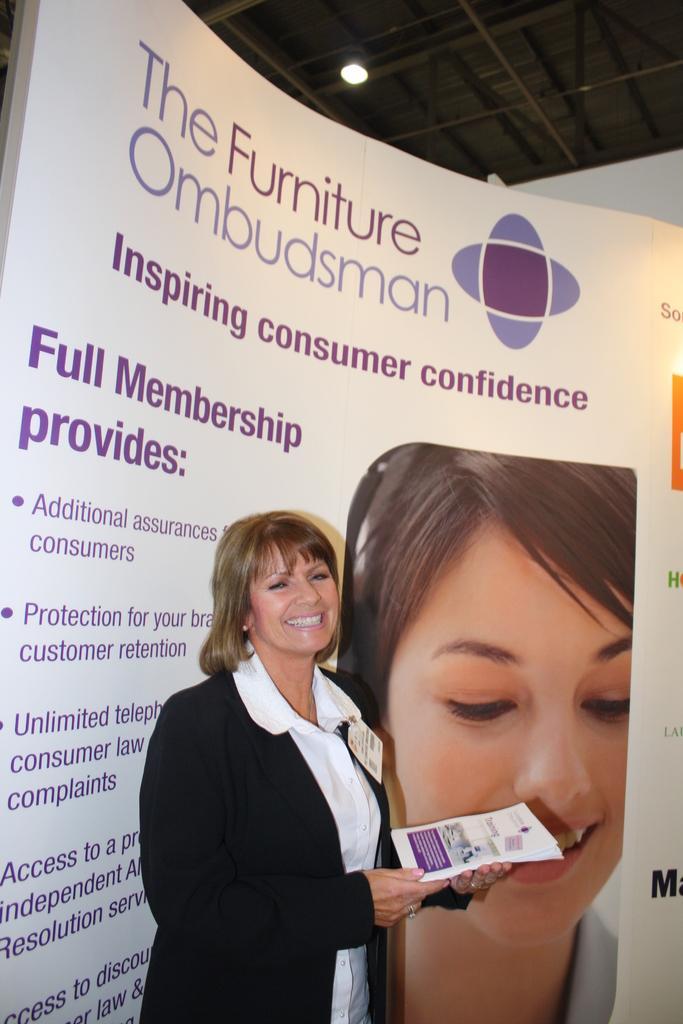How would you summarize this image in a sentence or two? In the center of the image a lady is standing and holding the papers in her hand. In the background of the image board is there. At the top of the image roof and light are there. 